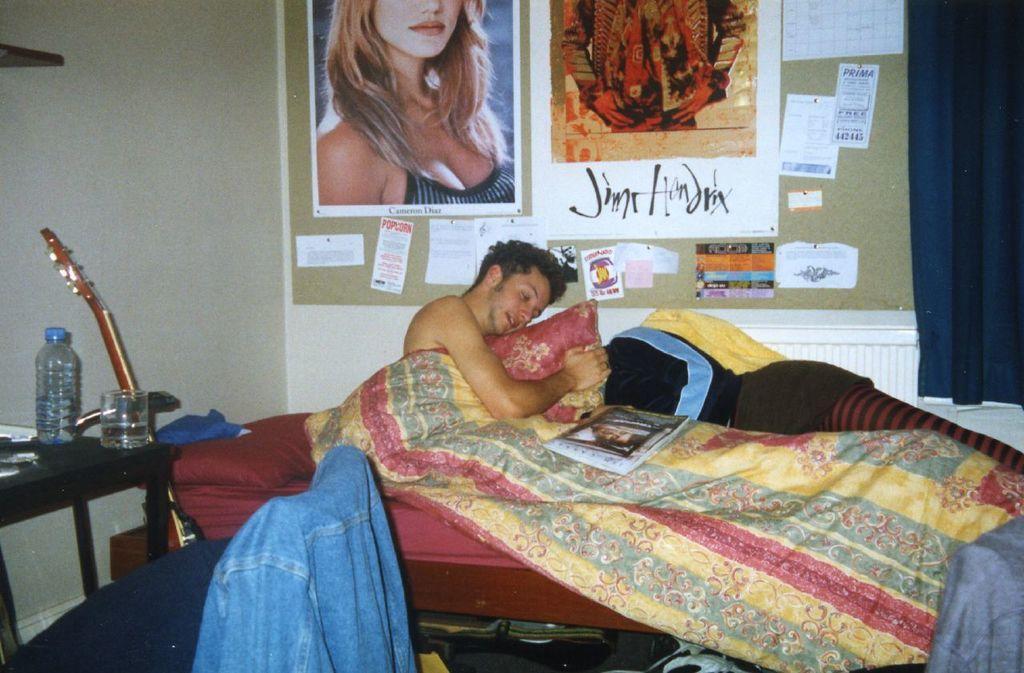Can you describe this image briefly? In this image I can see a bed and on it I can see a blanket, a book and a man. I can also see one more person over here. Here on this table I can see a glass, a bottle and few other stuffs. I can also see a guitar, few clothes and few posters on this wall. I can also see few papers on wall and on these papers I can see something is written. 